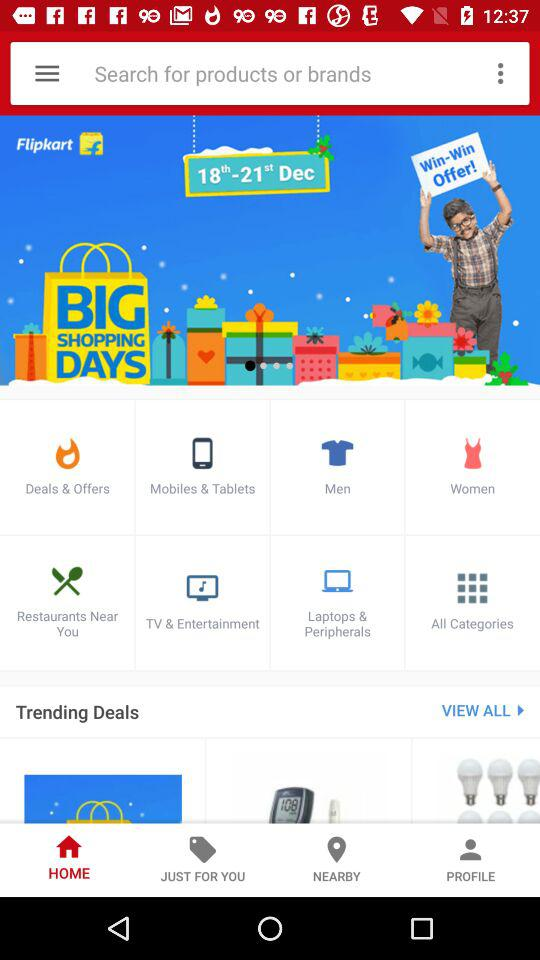What is the date range for big shopping day? The date range is from December 18th to December 21st. 